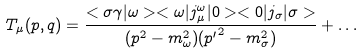Convert formula to latex. <formula><loc_0><loc_0><loc_500><loc_500>T _ { \mu } ( p , q ) = \frac { < \sigma \gamma | \omega > < \omega | j _ { \mu } ^ { \omega } | 0 > < 0 | j _ { \sigma } | \sigma > } { ( p ^ { 2 } - m ^ { 2 } _ { \omega } ) ( { p ^ { \prime } } ^ { 2 } - m ^ { 2 } _ { \sigma } ) } + \dots</formula> 